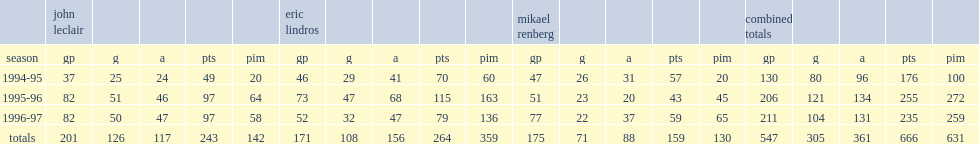Legion of doom's last season was 1996-97, how many goals did they score? 104.0. Legion of doom's last season was 1996-97, how many assists did they score? 131.0. 